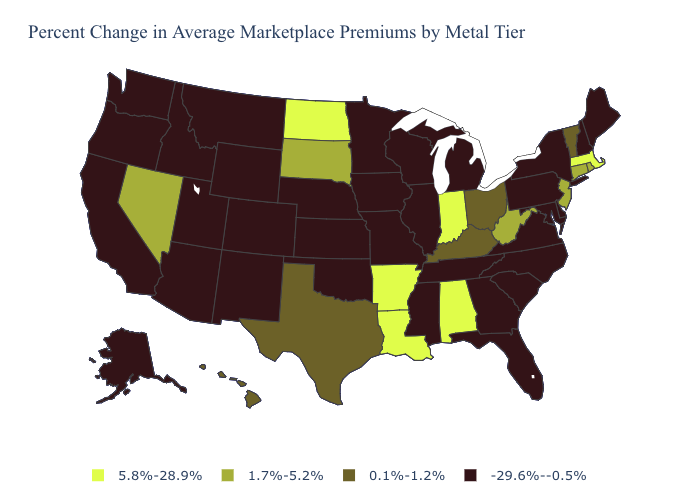Name the states that have a value in the range 5.8%-28.9%?
Quick response, please. Alabama, Arkansas, Indiana, Louisiana, Massachusetts, North Dakota. What is the value of Louisiana?
Concise answer only. 5.8%-28.9%. Name the states that have a value in the range 0.1%-1.2%?
Be succinct. Hawaii, Kentucky, Ohio, Texas, Vermont. Among the states that border Virginia , does Tennessee have the lowest value?
Keep it brief. Yes. What is the value of Utah?
Short answer required. -29.6%--0.5%. Name the states that have a value in the range 0.1%-1.2%?
Short answer required. Hawaii, Kentucky, Ohio, Texas, Vermont. Does Indiana have the highest value in the MidWest?
Quick response, please. Yes. Name the states that have a value in the range 1.7%-5.2%?
Concise answer only. Connecticut, Nevada, New Jersey, Rhode Island, South Dakota, West Virginia. Which states have the lowest value in the Northeast?
Give a very brief answer. Maine, New Hampshire, New York, Pennsylvania. Which states hav the highest value in the Northeast?
Write a very short answer. Massachusetts. What is the lowest value in states that border Montana?
Short answer required. -29.6%--0.5%. Does Florida have the highest value in the South?
Keep it brief. No. Name the states that have a value in the range 1.7%-5.2%?
Concise answer only. Connecticut, Nevada, New Jersey, Rhode Island, South Dakota, West Virginia. What is the lowest value in the Northeast?
Concise answer only. -29.6%--0.5%. Does the map have missing data?
Write a very short answer. No. 